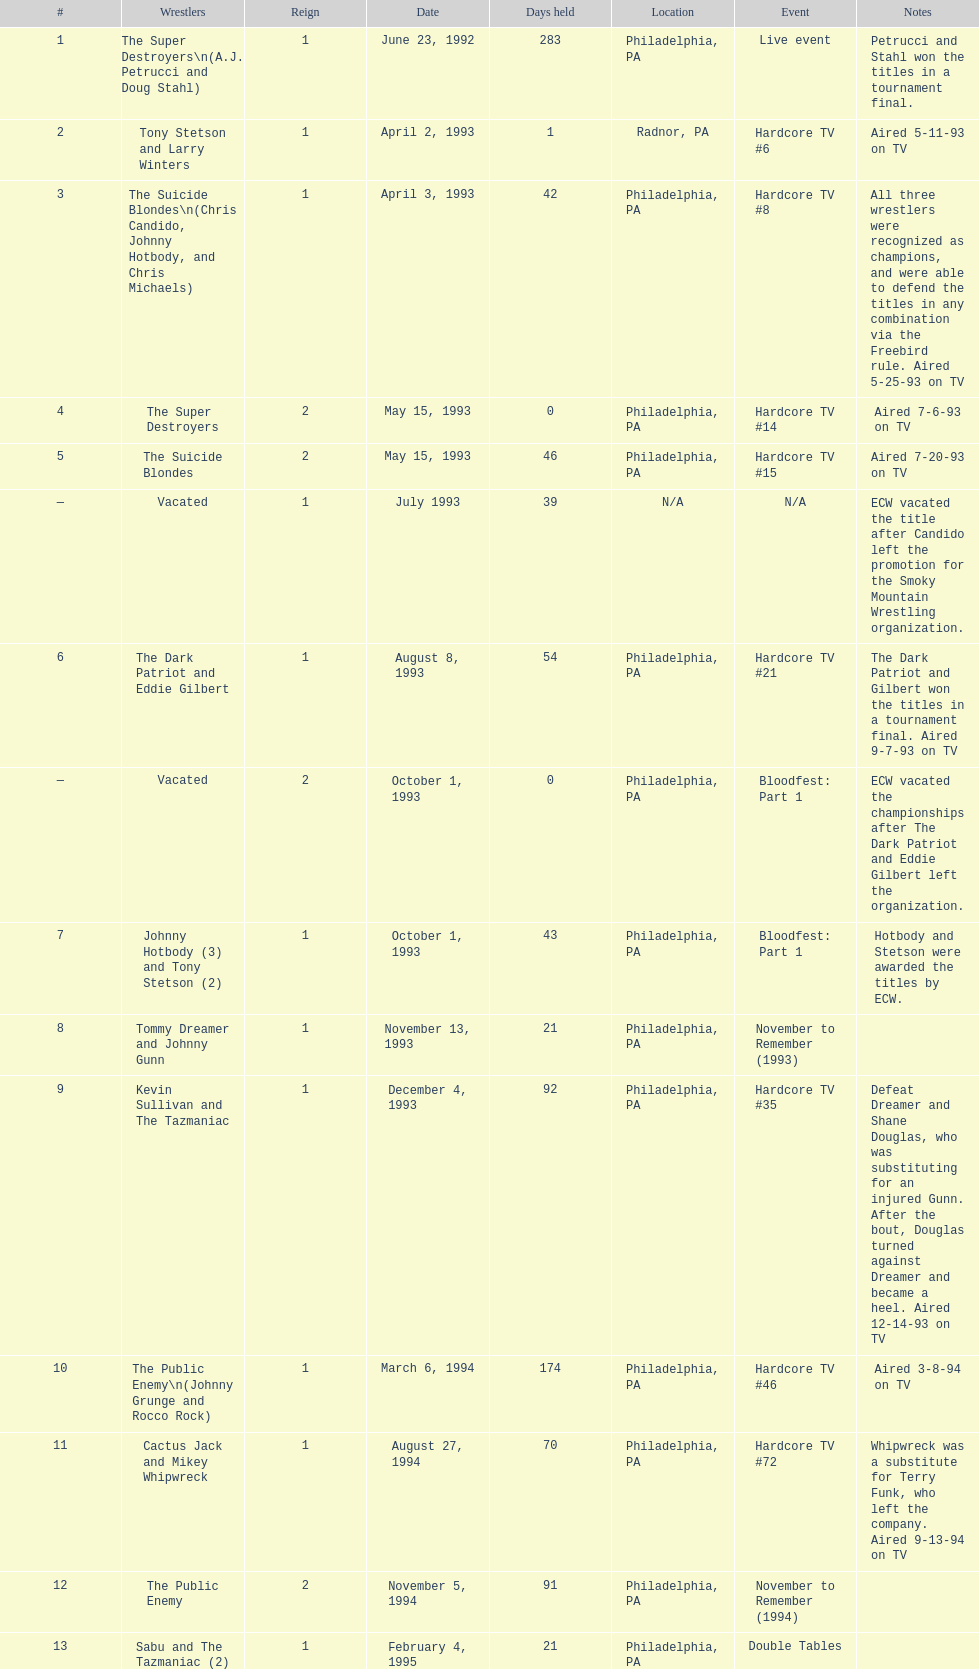From june 23, 1992 to december 3, 2000, how many occasions did the suicide blondes secure the title? 2. 